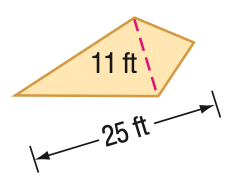Question: Find the area of the kite.
Choices:
A. 137.5
B. 255
C. 265
D. 550
Answer with the letter. Answer: A 